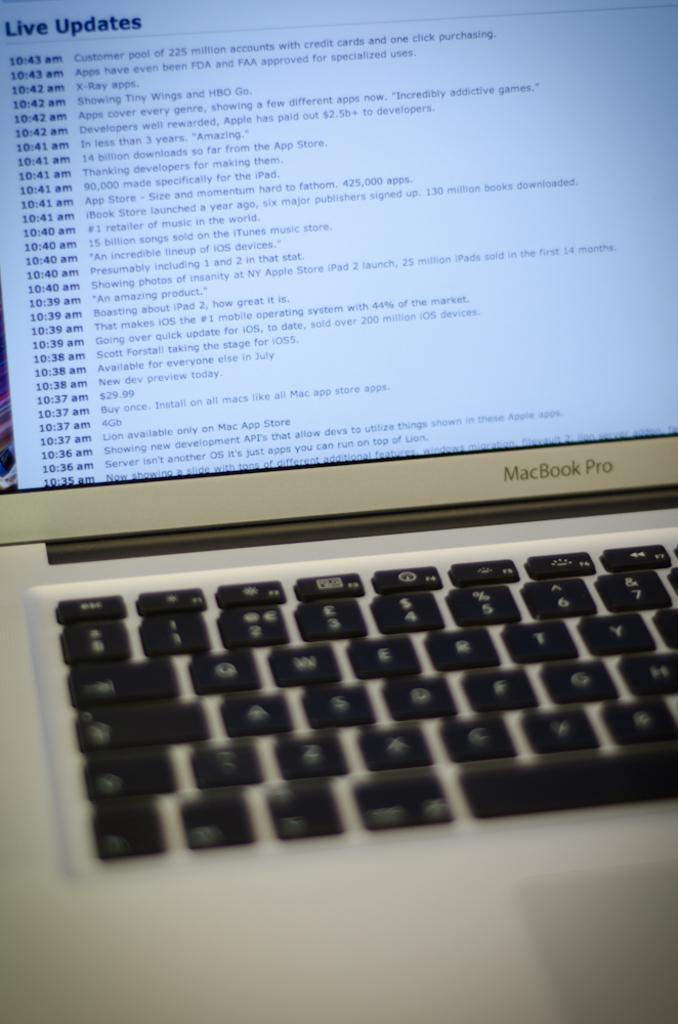What brand of laptop is this?
Ensure brevity in your answer.  Macbook pro. What kind of updates?
Offer a very short reply. Live. 